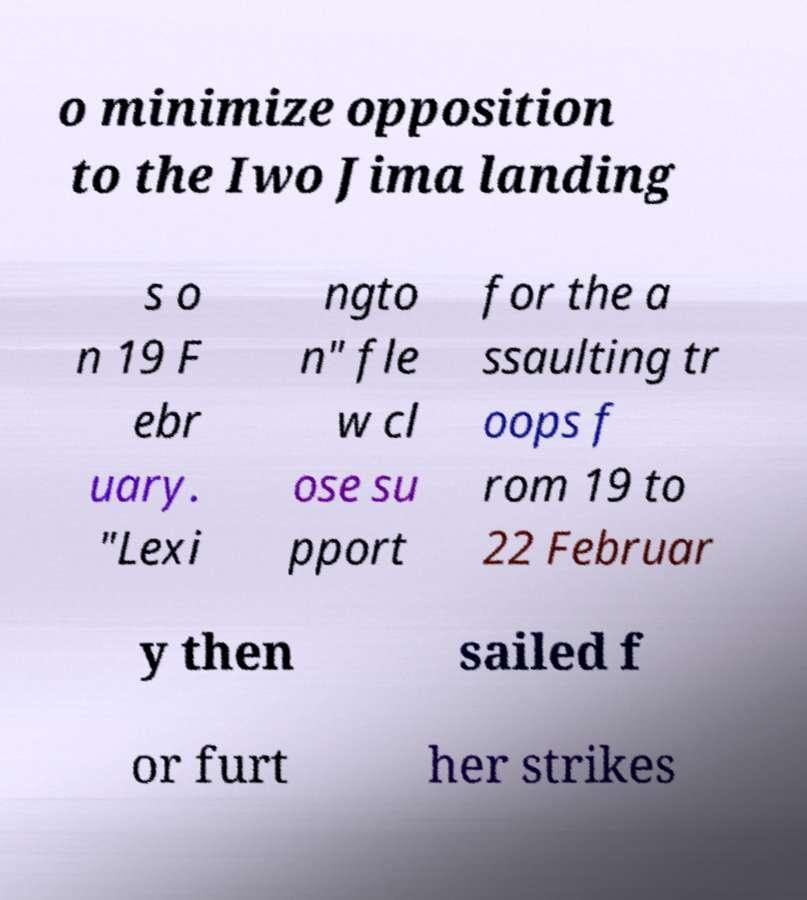Please read and relay the text visible in this image. What does it say? o minimize opposition to the Iwo Jima landing s o n 19 F ebr uary. "Lexi ngto n" fle w cl ose su pport for the a ssaulting tr oops f rom 19 to 22 Februar y then sailed f or furt her strikes 